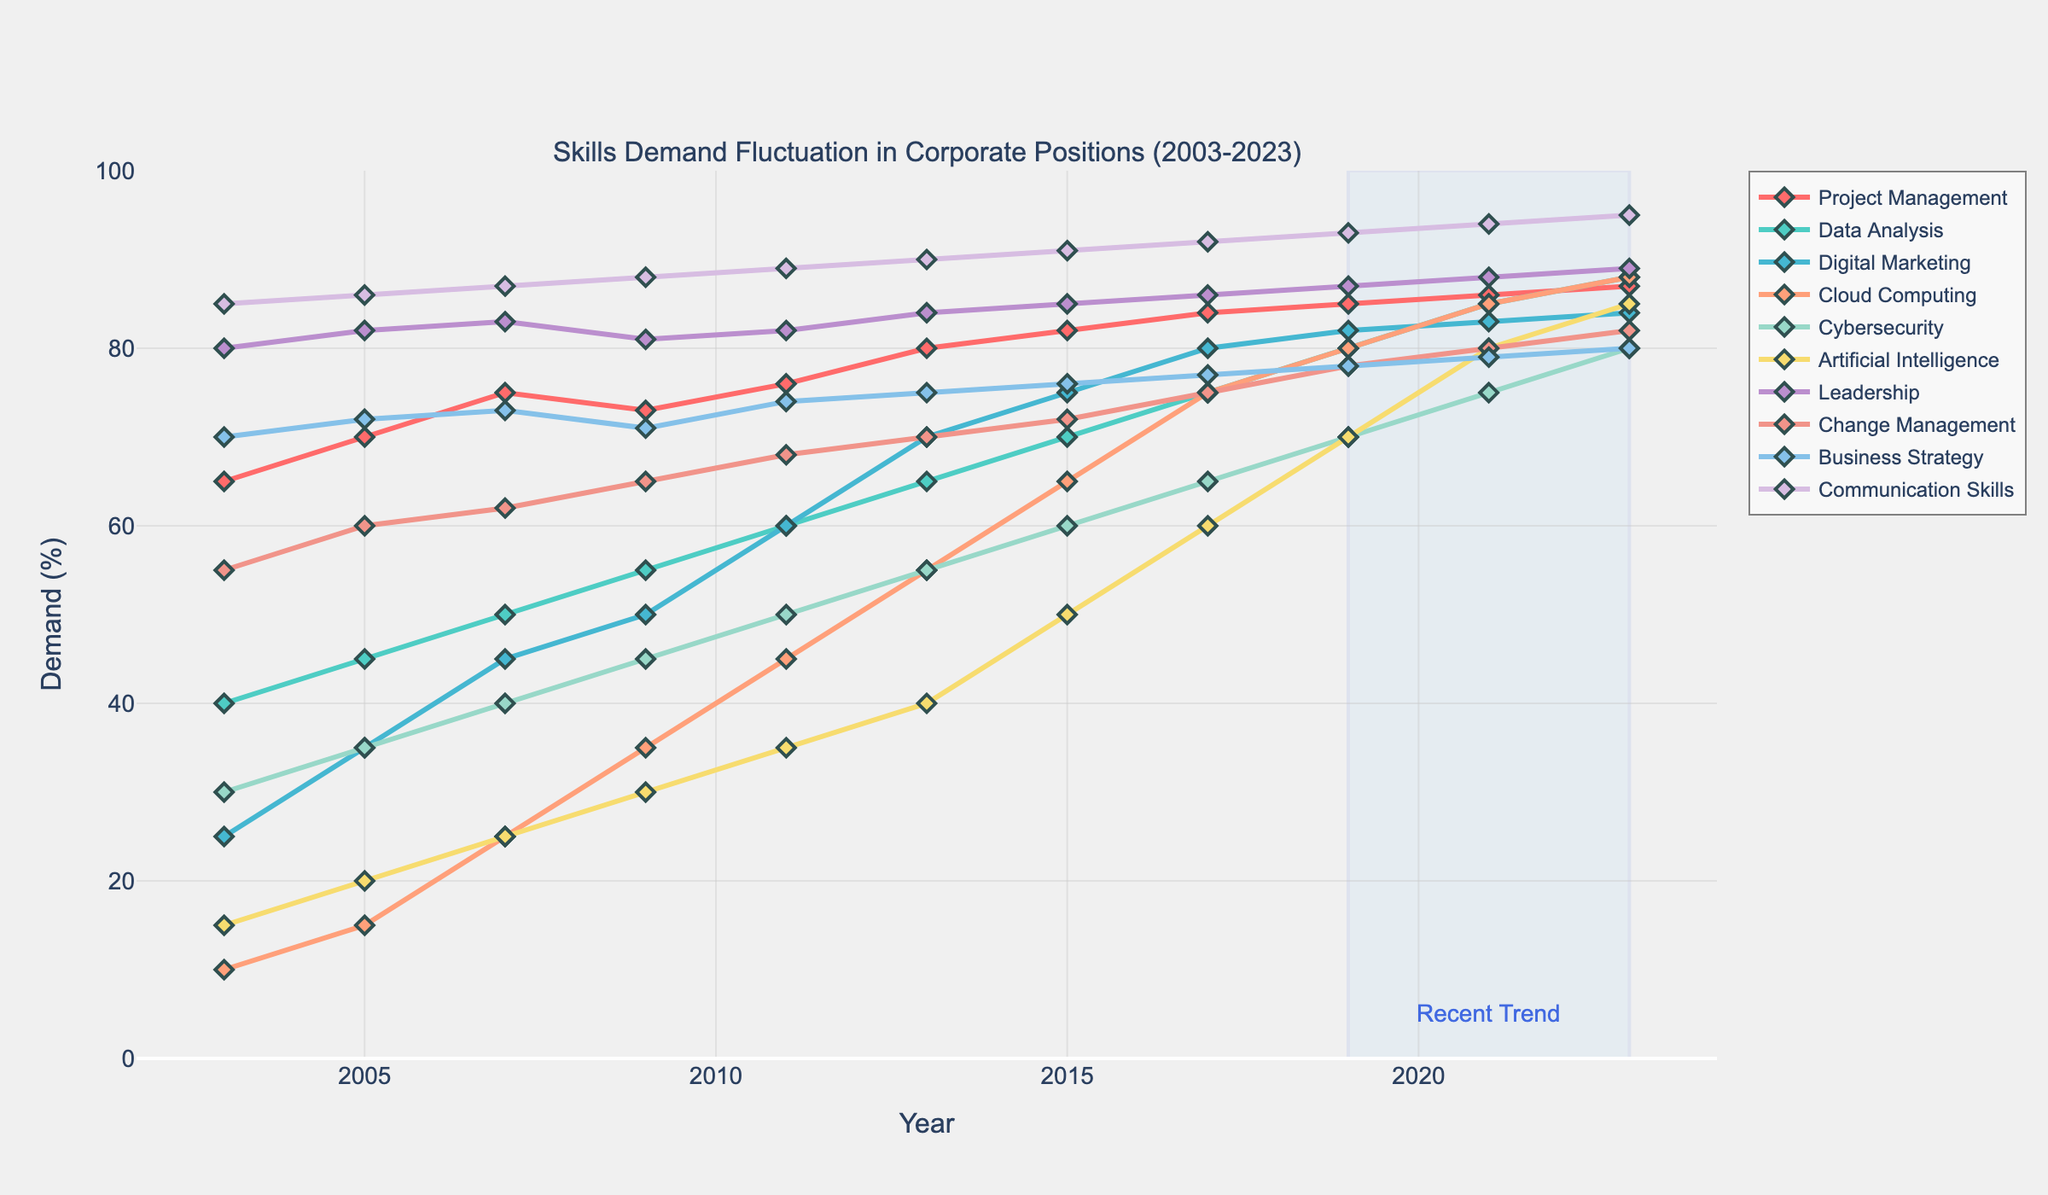What skill showed the highest demand fluctuation over the 20 years? To determine the skill with the highest fluctuation, observe the lines on the chart. The skill with a line that has the greatest amplitude (distance between peak and trough) has the highest fluctuation. Cybersecurity fluctuates from 30% to 80%, demonstrating the highest fluctuation.
Answer: Cybersecurity Which two skills had almost parallel growth trends between 2003 and 2023? Parallel growth trends can be identified by looking for similar slopes and patterns over time in the lines representing the skills. Digital Marketing and Artificial Intelligence lines are quite similar in growth patterns, both showing a steady increase.
Answer: Digital Marketing and Artificial Intelligence What's the average demand for Leadership over the 20 years? To calculate the average demand of Leadership, sum the demands over each year and divide by the number of years. The total demand from the data provided (80 + 82 + 83 + 81 + 82 + 84 + 85 + 86 + 87 + 88 + 89) is 927. Dividing by 11 (number of years) gives 927/11 = 84.27.
Answer: 84.27 In which year did Change Management see the biggest percent gain from the previous recorded year? To find the biggest percent gain, look at the differences between consecutive years. The biggest change in Change Management is between 2009 (65%) and 2011 (68%), an increase of 3% from the previous year.
Answer: 2011 Which skill has consistently had the highest demand from 2003 to 2023? A skill with consistently the highest demand would have its line always on top or near the top of the chart. Communication Skills has consistently higher demand values across all years depicted (85-95).
Answer: Communication Skills From 2019 to 2023, which skill experienced the most significant increase in demand? Comparing the values from 2019 to 2023 for each skill, the biggest increase can be found by looking for the largest value change. Cloud Computing went from 80% to 88%, an 8% increase, which is the largest among all skills.
Answer: Cloud Computing How does the demand for Business Strategy in 2023 compare to its demand in 2003? By comparing the two specific points of interest in the chart, Business Strategy was 70% in 2003 and increased to 80% in 2023.
Answer: Higher in 2023 What is the combined demand for Project Management and Data Analysis in 2013? Add the values for Project Management (80%) and Data Analysis (65%) for the year 2013. The combined demand is 80 + 65 = 145%.
Answer: 145% Which skill saw a decrease in demand from 2009 to 2011? By examining the lines corresponding to the years 2009 and 2011 for all skills, Project Management dropped from 73% in 2009 to 71% in 2011.
Answer: Project Management Between 2011 and 2015, what was the percentage increase for Cloud Computing? Calculate the difference in value for Cloud Computing between 2011 (45%) and 2015 (65%). The increase is 65 - 45 = 20%. Further, the percentage increase is (20 / 45) * 100 = 44.44%.
Answer: 44.44% 